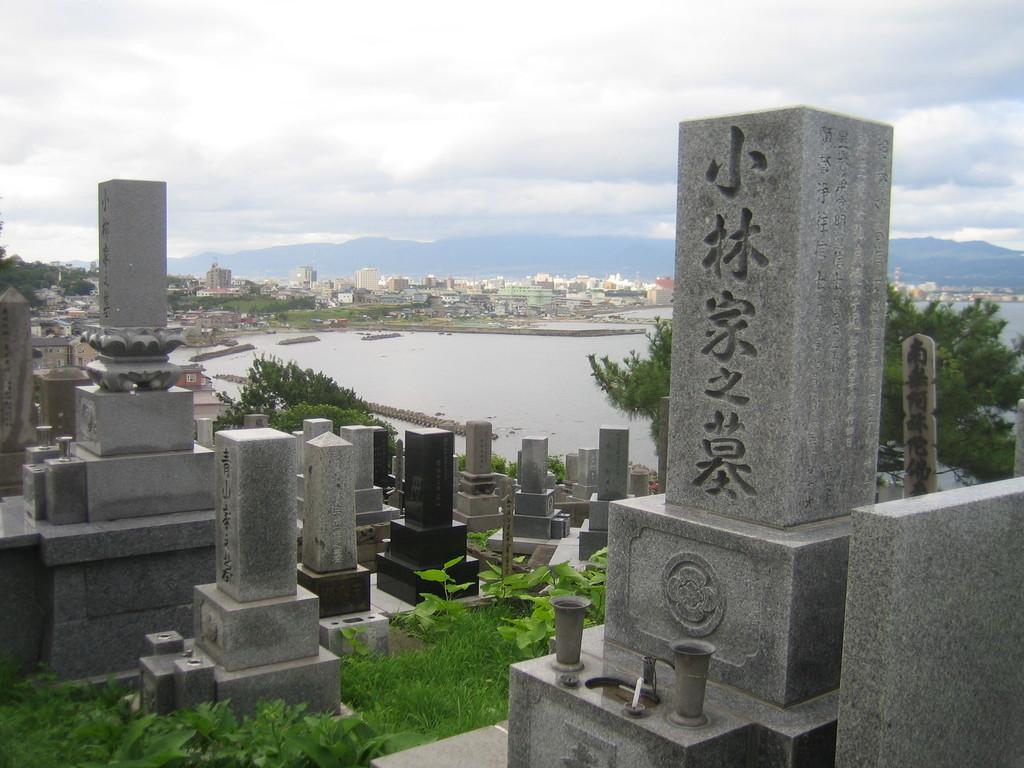Could you give a brief overview of what you see in this image? In this image in the middle I can see the lake, buildings , at the top I can see the sky , in the foreground I can see group of cemetery and grass and plant. 